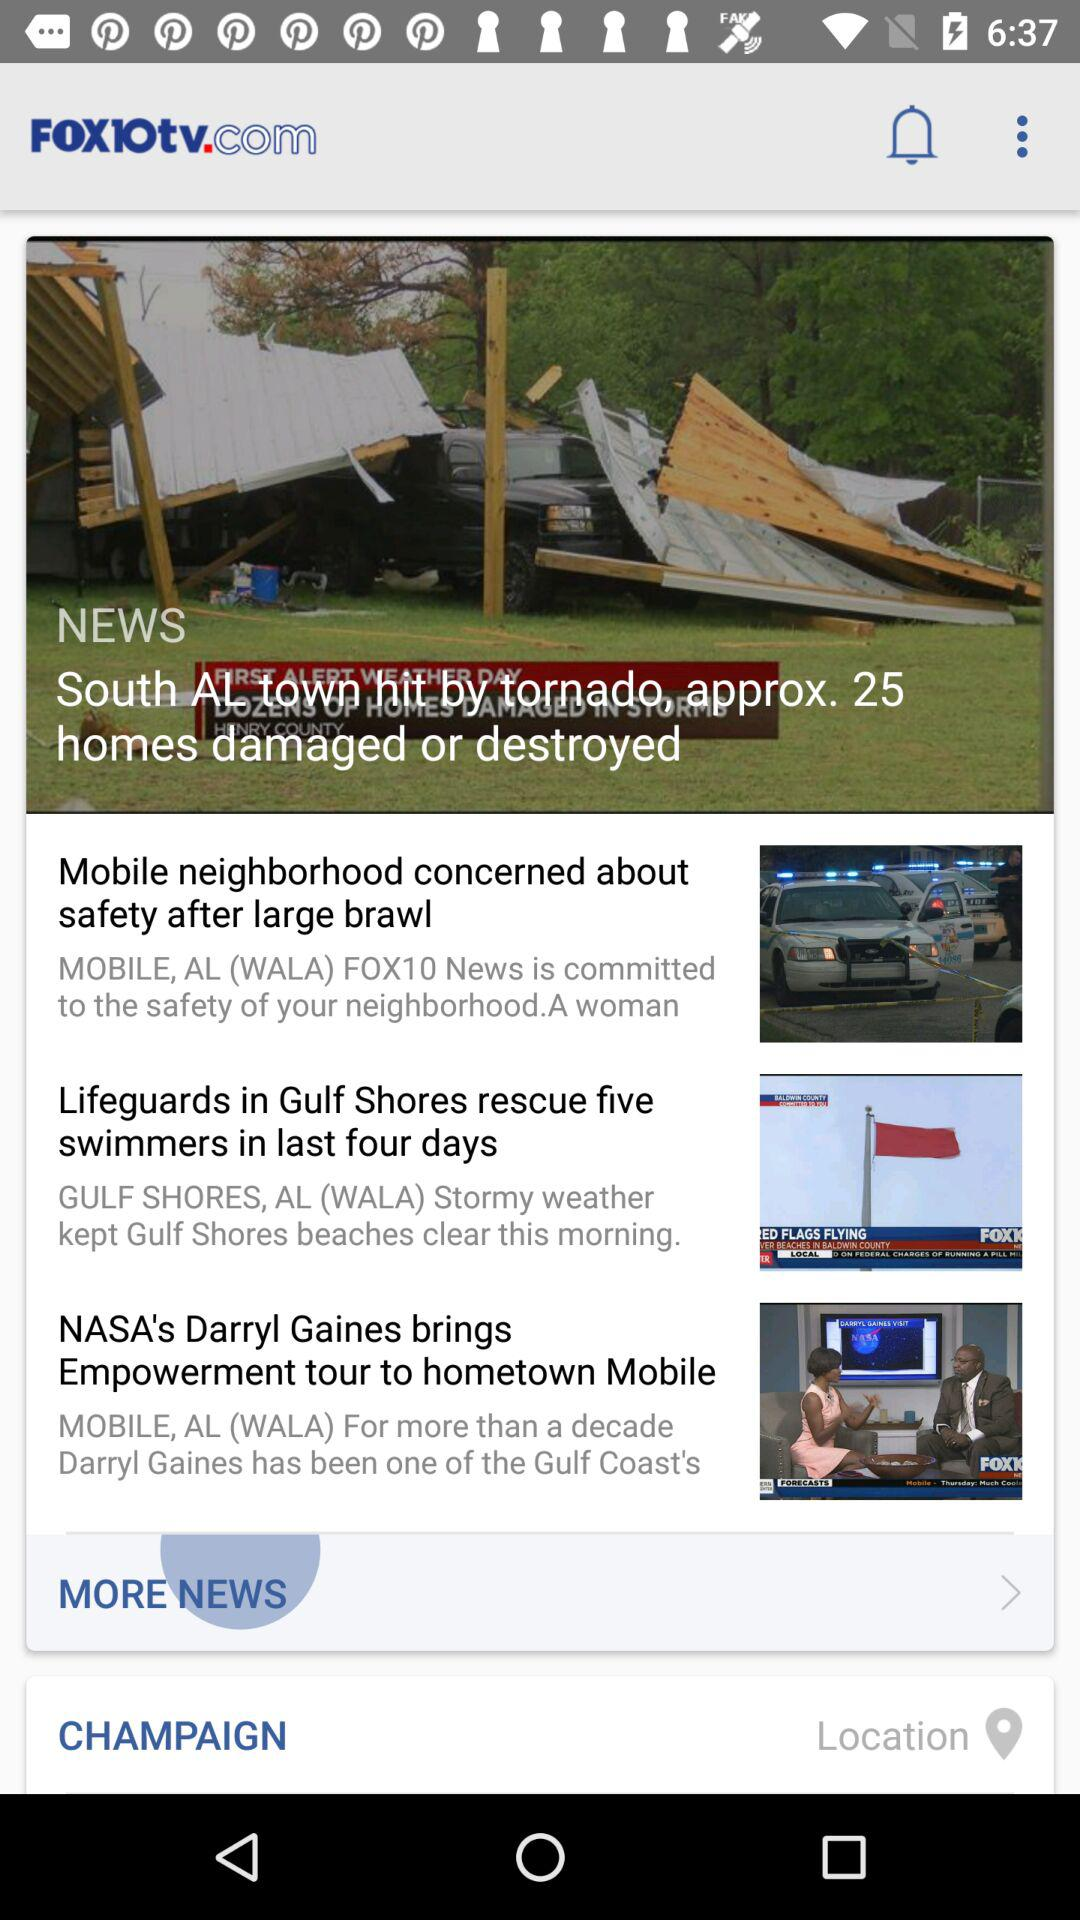What is the name of the application? The name of the application is "FOX1Otv.com". 